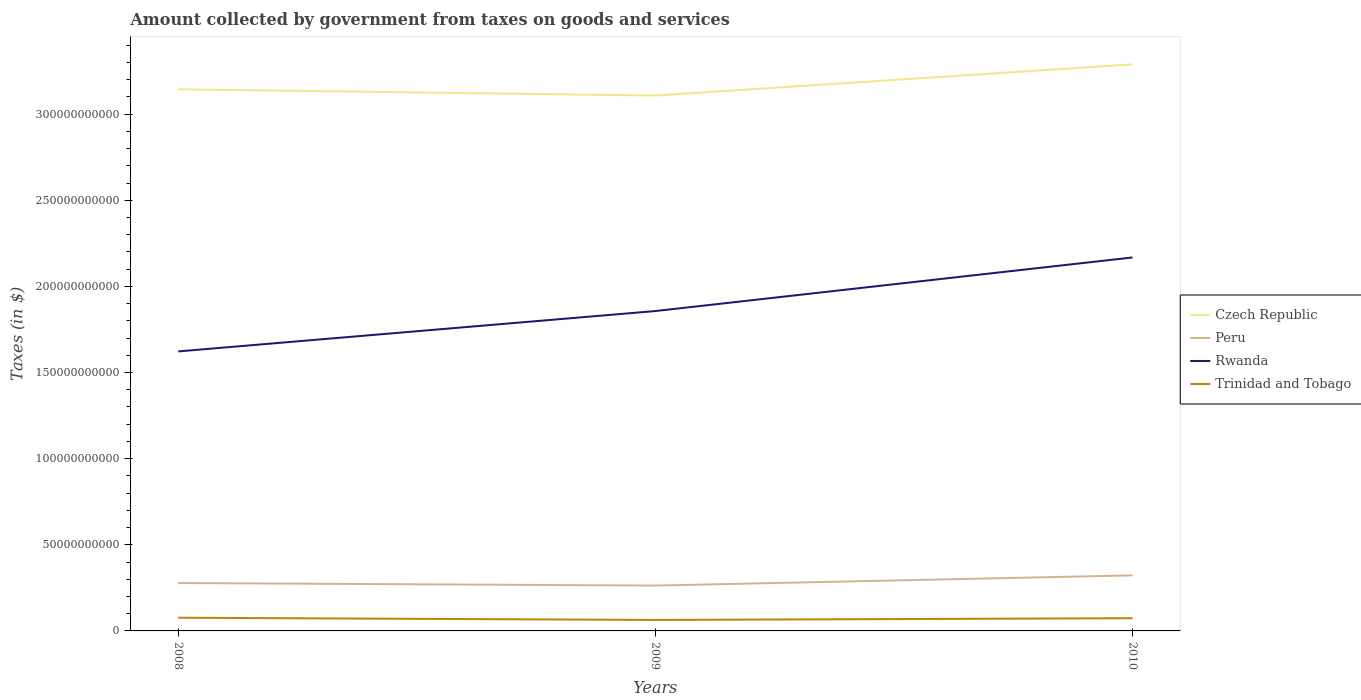How many different coloured lines are there?
Your response must be concise. 4. Across all years, what is the maximum amount collected by government from taxes on goods and services in Rwanda?
Your answer should be compact. 1.62e+11. What is the total amount collected by government from taxes on goods and services in Czech Republic in the graph?
Ensure brevity in your answer.  -1.81e+1. What is the difference between the highest and the second highest amount collected by government from taxes on goods and services in Trinidad and Tobago?
Give a very brief answer. 1.28e+09. Is the amount collected by government from taxes on goods and services in Trinidad and Tobago strictly greater than the amount collected by government from taxes on goods and services in Czech Republic over the years?
Your answer should be compact. Yes. How many lines are there?
Offer a very short reply. 4. Are the values on the major ticks of Y-axis written in scientific E-notation?
Your answer should be very brief. No. How are the legend labels stacked?
Your response must be concise. Vertical. What is the title of the graph?
Make the answer very short. Amount collected by government from taxes on goods and services. Does "Cameroon" appear as one of the legend labels in the graph?
Your response must be concise. No. What is the label or title of the X-axis?
Ensure brevity in your answer.  Years. What is the label or title of the Y-axis?
Provide a short and direct response. Taxes (in $). What is the Taxes (in $) of Czech Republic in 2008?
Make the answer very short. 3.14e+11. What is the Taxes (in $) of Peru in 2008?
Provide a short and direct response. 2.78e+1. What is the Taxes (in $) of Rwanda in 2008?
Keep it short and to the point. 1.62e+11. What is the Taxes (in $) of Trinidad and Tobago in 2008?
Your answer should be very brief. 7.66e+09. What is the Taxes (in $) in Czech Republic in 2009?
Make the answer very short. 3.11e+11. What is the Taxes (in $) of Peru in 2009?
Make the answer very short. 2.63e+1. What is the Taxes (in $) of Rwanda in 2009?
Make the answer very short. 1.86e+11. What is the Taxes (in $) in Trinidad and Tobago in 2009?
Keep it short and to the point. 6.38e+09. What is the Taxes (in $) of Czech Republic in 2010?
Your answer should be compact. 3.29e+11. What is the Taxes (in $) in Peru in 2010?
Make the answer very short. 3.23e+1. What is the Taxes (in $) in Rwanda in 2010?
Give a very brief answer. 2.17e+11. What is the Taxes (in $) of Trinidad and Tobago in 2010?
Your answer should be compact. 7.38e+09. Across all years, what is the maximum Taxes (in $) of Czech Republic?
Keep it short and to the point. 3.29e+11. Across all years, what is the maximum Taxes (in $) of Peru?
Give a very brief answer. 3.23e+1. Across all years, what is the maximum Taxes (in $) of Rwanda?
Give a very brief answer. 2.17e+11. Across all years, what is the maximum Taxes (in $) in Trinidad and Tobago?
Keep it short and to the point. 7.66e+09. Across all years, what is the minimum Taxes (in $) of Czech Republic?
Keep it short and to the point. 3.11e+11. Across all years, what is the minimum Taxes (in $) in Peru?
Keep it short and to the point. 2.63e+1. Across all years, what is the minimum Taxes (in $) in Rwanda?
Provide a succinct answer. 1.62e+11. Across all years, what is the minimum Taxes (in $) of Trinidad and Tobago?
Ensure brevity in your answer.  6.38e+09. What is the total Taxes (in $) of Czech Republic in the graph?
Give a very brief answer. 9.54e+11. What is the total Taxes (in $) in Peru in the graph?
Your response must be concise. 8.64e+1. What is the total Taxes (in $) of Rwanda in the graph?
Offer a terse response. 5.65e+11. What is the total Taxes (in $) of Trinidad and Tobago in the graph?
Keep it short and to the point. 2.14e+1. What is the difference between the Taxes (in $) in Czech Republic in 2008 and that in 2009?
Offer a very short reply. 3.63e+09. What is the difference between the Taxes (in $) in Peru in 2008 and that in 2009?
Keep it short and to the point. 1.49e+09. What is the difference between the Taxes (in $) in Rwanda in 2008 and that in 2009?
Provide a short and direct response. -2.34e+1. What is the difference between the Taxes (in $) in Trinidad and Tobago in 2008 and that in 2009?
Your answer should be compact. 1.28e+09. What is the difference between the Taxes (in $) of Czech Republic in 2008 and that in 2010?
Make the answer very short. -1.45e+1. What is the difference between the Taxes (in $) of Peru in 2008 and that in 2010?
Make the answer very short. -4.44e+09. What is the difference between the Taxes (in $) in Rwanda in 2008 and that in 2010?
Offer a terse response. -5.45e+1. What is the difference between the Taxes (in $) in Trinidad and Tobago in 2008 and that in 2010?
Offer a very short reply. 2.76e+08. What is the difference between the Taxes (in $) of Czech Republic in 2009 and that in 2010?
Provide a short and direct response. -1.81e+1. What is the difference between the Taxes (in $) in Peru in 2009 and that in 2010?
Offer a very short reply. -5.93e+09. What is the difference between the Taxes (in $) in Rwanda in 2009 and that in 2010?
Your response must be concise. -3.11e+1. What is the difference between the Taxes (in $) of Trinidad and Tobago in 2009 and that in 2010?
Keep it short and to the point. -1.01e+09. What is the difference between the Taxes (in $) of Czech Republic in 2008 and the Taxes (in $) of Peru in 2009?
Provide a succinct answer. 2.88e+11. What is the difference between the Taxes (in $) in Czech Republic in 2008 and the Taxes (in $) in Rwanda in 2009?
Keep it short and to the point. 1.29e+11. What is the difference between the Taxes (in $) in Czech Republic in 2008 and the Taxes (in $) in Trinidad and Tobago in 2009?
Your answer should be compact. 3.08e+11. What is the difference between the Taxes (in $) in Peru in 2008 and the Taxes (in $) in Rwanda in 2009?
Offer a very short reply. -1.58e+11. What is the difference between the Taxes (in $) in Peru in 2008 and the Taxes (in $) in Trinidad and Tobago in 2009?
Your response must be concise. 2.14e+1. What is the difference between the Taxes (in $) of Rwanda in 2008 and the Taxes (in $) of Trinidad and Tobago in 2009?
Your answer should be compact. 1.56e+11. What is the difference between the Taxes (in $) in Czech Republic in 2008 and the Taxes (in $) in Peru in 2010?
Your answer should be very brief. 2.82e+11. What is the difference between the Taxes (in $) of Czech Republic in 2008 and the Taxes (in $) of Rwanda in 2010?
Your response must be concise. 9.76e+1. What is the difference between the Taxes (in $) of Czech Republic in 2008 and the Taxes (in $) of Trinidad and Tobago in 2010?
Keep it short and to the point. 3.07e+11. What is the difference between the Taxes (in $) of Peru in 2008 and the Taxes (in $) of Rwanda in 2010?
Make the answer very short. -1.89e+11. What is the difference between the Taxes (in $) in Peru in 2008 and the Taxes (in $) in Trinidad and Tobago in 2010?
Offer a terse response. 2.04e+1. What is the difference between the Taxes (in $) of Rwanda in 2008 and the Taxes (in $) of Trinidad and Tobago in 2010?
Offer a terse response. 1.55e+11. What is the difference between the Taxes (in $) in Czech Republic in 2009 and the Taxes (in $) in Peru in 2010?
Provide a short and direct response. 2.79e+11. What is the difference between the Taxes (in $) in Czech Republic in 2009 and the Taxes (in $) in Rwanda in 2010?
Keep it short and to the point. 9.40e+1. What is the difference between the Taxes (in $) in Czech Republic in 2009 and the Taxes (in $) in Trinidad and Tobago in 2010?
Your answer should be compact. 3.03e+11. What is the difference between the Taxes (in $) of Peru in 2009 and the Taxes (in $) of Rwanda in 2010?
Offer a very short reply. -1.90e+11. What is the difference between the Taxes (in $) of Peru in 2009 and the Taxes (in $) of Trinidad and Tobago in 2010?
Ensure brevity in your answer.  1.89e+1. What is the difference between the Taxes (in $) in Rwanda in 2009 and the Taxes (in $) in Trinidad and Tobago in 2010?
Offer a terse response. 1.78e+11. What is the average Taxes (in $) in Czech Republic per year?
Ensure brevity in your answer.  3.18e+11. What is the average Taxes (in $) of Peru per year?
Give a very brief answer. 2.88e+1. What is the average Taxes (in $) of Rwanda per year?
Your answer should be compact. 1.88e+11. What is the average Taxes (in $) in Trinidad and Tobago per year?
Make the answer very short. 7.14e+09. In the year 2008, what is the difference between the Taxes (in $) in Czech Republic and Taxes (in $) in Peru?
Your answer should be compact. 2.87e+11. In the year 2008, what is the difference between the Taxes (in $) of Czech Republic and Taxes (in $) of Rwanda?
Offer a terse response. 1.52e+11. In the year 2008, what is the difference between the Taxes (in $) in Czech Republic and Taxes (in $) in Trinidad and Tobago?
Your response must be concise. 3.07e+11. In the year 2008, what is the difference between the Taxes (in $) in Peru and Taxes (in $) in Rwanda?
Your response must be concise. -1.34e+11. In the year 2008, what is the difference between the Taxes (in $) in Peru and Taxes (in $) in Trinidad and Tobago?
Provide a succinct answer. 2.02e+1. In the year 2008, what is the difference between the Taxes (in $) of Rwanda and Taxes (in $) of Trinidad and Tobago?
Make the answer very short. 1.55e+11. In the year 2009, what is the difference between the Taxes (in $) of Czech Republic and Taxes (in $) of Peru?
Your answer should be very brief. 2.84e+11. In the year 2009, what is the difference between the Taxes (in $) in Czech Republic and Taxes (in $) in Rwanda?
Your answer should be compact. 1.25e+11. In the year 2009, what is the difference between the Taxes (in $) in Czech Republic and Taxes (in $) in Trinidad and Tobago?
Offer a terse response. 3.04e+11. In the year 2009, what is the difference between the Taxes (in $) of Peru and Taxes (in $) of Rwanda?
Your response must be concise. -1.59e+11. In the year 2009, what is the difference between the Taxes (in $) of Peru and Taxes (in $) of Trinidad and Tobago?
Your answer should be compact. 1.99e+1. In the year 2009, what is the difference between the Taxes (in $) of Rwanda and Taxes (in $) of Trinidad and Tobago?
Your response must be concise. 1.79e+11. In the year 2010, what is the difference between the Taxes (in $) in Czech Republic and Taxes (in $) in Peru?
Provide a succinct answer. 2.97e+11. In the year 2010, what is the difference between the Taxes (in $) in Czech Republic and Taxes (in $) in Rwanda?
Offer a terse response. 1.12e+11. In the year 2010, what is the difference between the Taxes (in $) in Czech Republic and Taxes (in $) in Trinidad and Tobago?
Keep it short and to the point. 3.22e+11. In the year 2010, what is the difference between the Taxes (in $) of Peru and Taxes (in $) of Rwanda?
Your answer should be compact. -1.85e+11. In the year 2010, what is the difference between the Taxes (in $) of Peru and Taxes (in $) of Trinidad and Tobago?
Provide a succinct answer. 2.49e+1. In the year 2010, what is the difference between the Taxes (in $) of Rwanda and Taxes (in $) of Trinidad and Tobago?
Keep it short and to the point. 2.09e+11. What is the ratio of the Taxes (in $) of Czech Republic in 2008 to that in 2009?
Your response must be concise. 1.01. What is the ratio of the Taxes (in $) in Peru in 2008 to that in 2009?
Keep it short and to the point. 1.06. What is the ratio of the Taxes (in $) of Rwanda in 2008 to that in 2009?
Your answer should be very brief. 0.87. What is the ratio of the Taxes (in $) of Trinidad and Tobago in 2008 to that in 2009?
Your response must be concise. 1.2. What is the ratio of the Taxes (in $) of Czech Republic in 2008 to that in 2010?
Keep it short and to the point. 0.96. What is the ratio of the Taxes (in $) in Peru in 2008 to that in 2010?
Ensure brevity in your answer.  0.86. What is the ratio of the Taxes (in $) of Rwanda in 2008 to that in 2010?
Offer a terse response. 0.75. What is the ratio of the Taxes (in $) of Trinidad and Tobago in 2008 to that in 2010?
Keep it short and to the point. 1.04. What is the ratio of the Taxes (in $) of Czech Republic in 2009 to that in 2010?
Your response must be concise. 0.94. What is the ratio of the Taxes (in $) in Peru in 2009 to that in 2010?
Provide a short and direct response. 0.82. What is the ratio of the Taxes (in $) of Rwanda in 2009 to that in 2010?
Offer a very short reply. 0.86. What is the ratio of the Taxes (in $) of Trinidad and Tobago in 2009 to that in 2010?
Your answer should be very brief. 0.86. What is the difference between the highest and the second highest Taxes (in $) of Czech Republic?
Provide a short and direct response. 1.45e+1. What is the difference between the highest and the second highest Taxes (in $) in Peru?
Provide a succinct answer. 4.44e+09. What is the difference between the highest and the second highest Taxes (in $) of Rwanda?
Provide a short and direct response. 3.11e+1. What is the difference between the highest and the second highest Taxes (in $) in Trinidad and Tobago?
Your answer should be very brief. 2.76e+08. What is the difference between the highest and the lowest Taxes (in $) of Czech Republic?
Provide a short and direct response. 1.81e+1. What is the difference between the highest and the lowest Taxes (in $) in Peru?
Your answer should be compact. 5.93e+09. What is the difference between the highest and the lowest Taxes (in $) in Rwanda?
Your answer should be compact. 5.45e+1. What is the difference between the highest and the lowest Taxes (in $) in Trinidad and Tobago?
Give a very brief answer. 1.28e+09. 